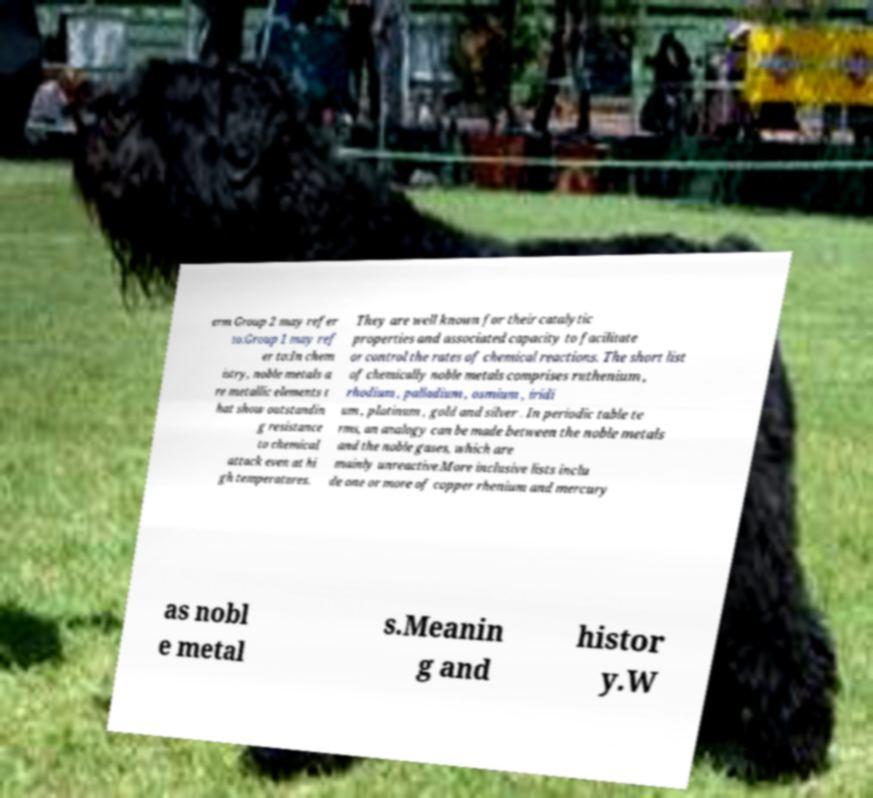Please read and relay the text visible in this image. What does it say? erm Group 2 may refer to:Group 1 may ref er to:In chem istry, noble metals a re metallic elements t hat show outstandin g resistance to chemical attack even at hi gh temperatures. They are well known for their catalytic properties and associated capacity to facilitate or control the rates of chemical reactions. The short list of chemically noble metals comprises ruthenium , rhodium , palladium , osmium , iridi um , platinum , gold and silver . In periodic table te rms, an analogy can be made between the noble metals and the noble gases, which are mainly unreactive.More inclusive lists inclu de one or more of copper rhenium and mercury as nobl e metal s.Meanin g and histor y.W 